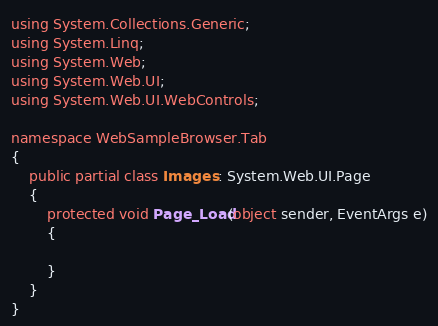<code> <loc_0><loc_0><loc_500><loc_500><_C#_>using System.Collections.Generic;
using System.Linq;
using System.Web;
using System.Web.UI;
using System.Web.UI.WebControls;

namespace WebSampleBrowser.Tab
{
    public partial class Images : System.Web.UI.Page
    {
        protected void Page_Load(object sender, EventArgs e)
        {

        }
    }
}</code> 